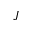<formula> <loc_0><loc_0><loc_500><loc_500>J</formula> 